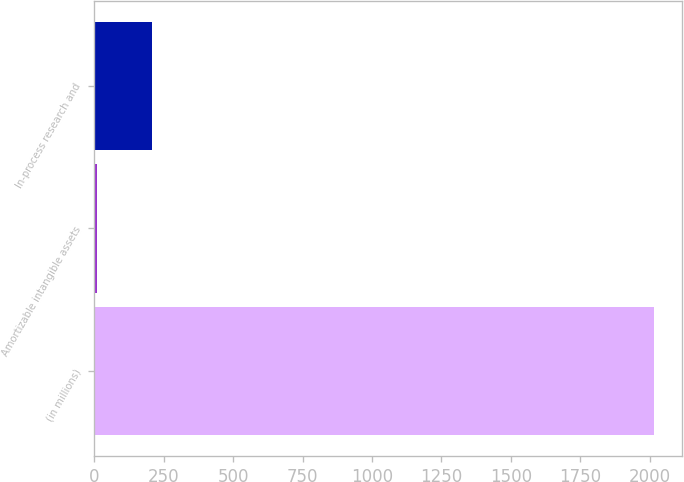Convert chart. <chart><loc_0><loc_0><loc_500><loc_500><bar_chart><fcel>(in millions)<fcel>Amortizable intangible assets<fcel>In-process research and<nl><fcel>2015<fcel>9<fcel>209.6<nl></chart> 